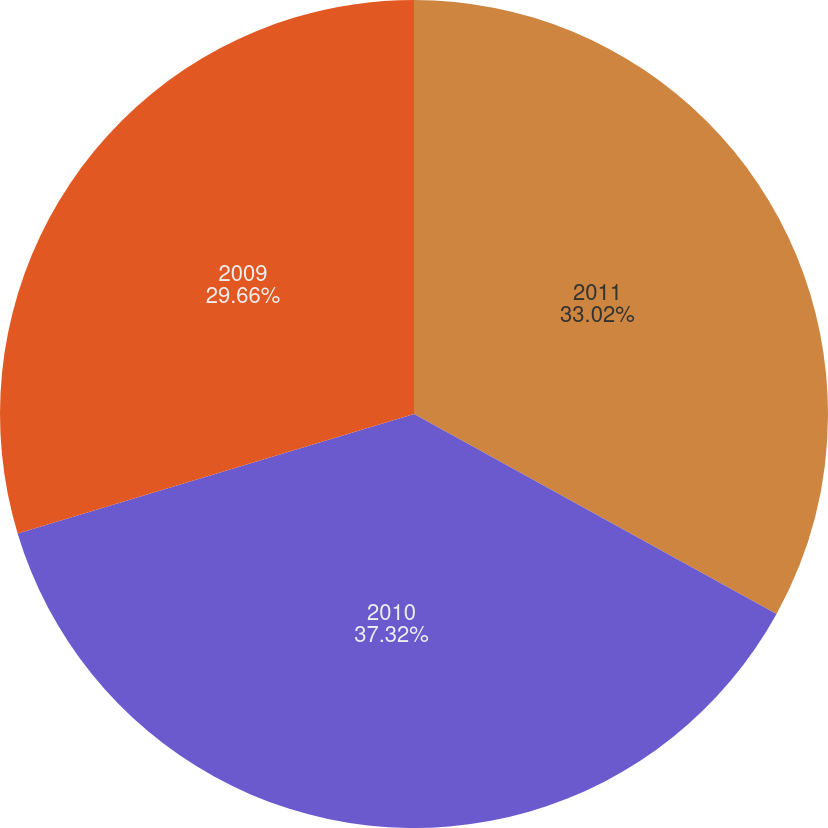<chart> <loc_0><loc_0><loc_500><loc_500><pie_chart><fcel>2011<fcel>2010<fcel>2009<nl><fcel>33.02%<fcel>37.32%<fcel>29.66%<nl></chart> 